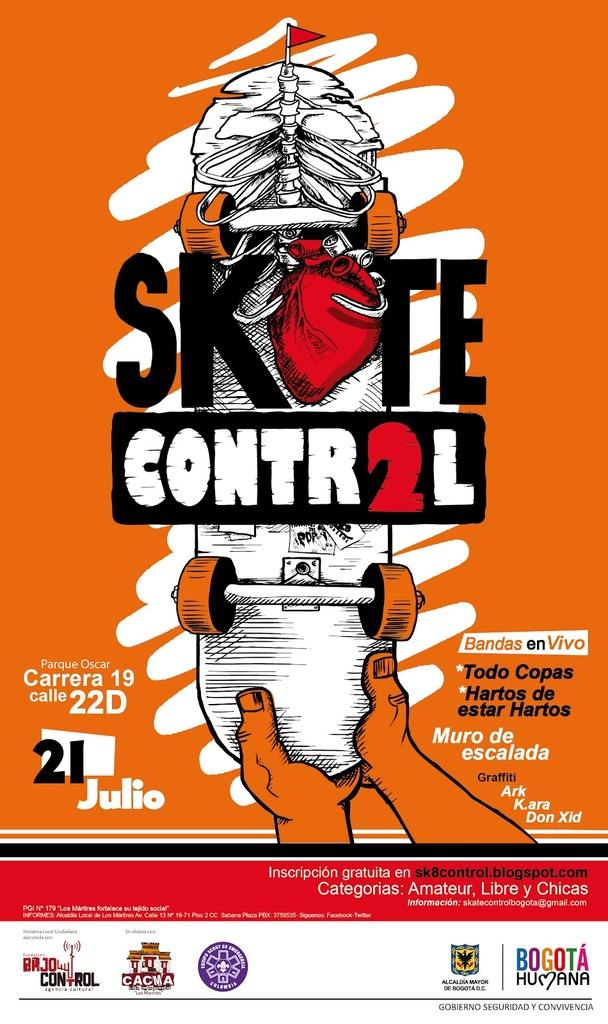<image>
Offer a succinct explanation of the picture presented. A poster advertisement for an event called Skate Control that shows hands holding a skateboard. 